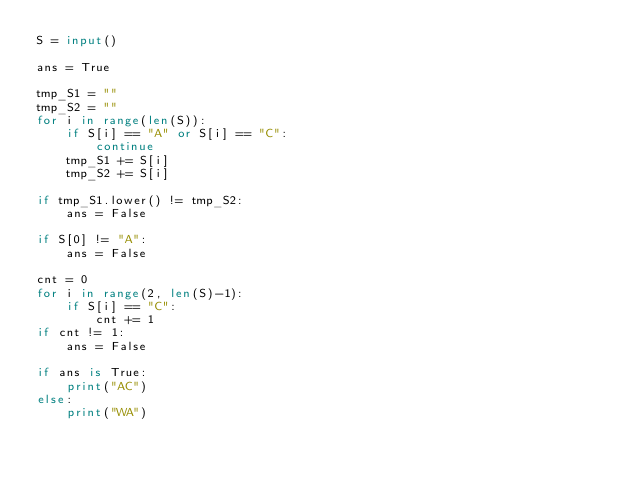Convert code to text. <code><loc_0><loc_0><loc_500><loc_500><_Python_>S = input()

ans = True

tmp_S1 = ""
tmp_S2 = ""
for i in range(len(S)):
    if S[i] == "A" or S[i] == "C":
        continue
    tmp_S1 += S[i]
    tmp_S2 += S[i]

if tmp_S1.lower() != tmp_S2:
    ans = False

if S[0] != "A":
    ans = False

cnt = 0
for i in range(2, len(S)-1):
    if S[i] == "C":
        cnt += 1
if cnt != 1:
    ans = False

if ans is True:
    print("AC")
else:
    print("WA")


    
</code> 